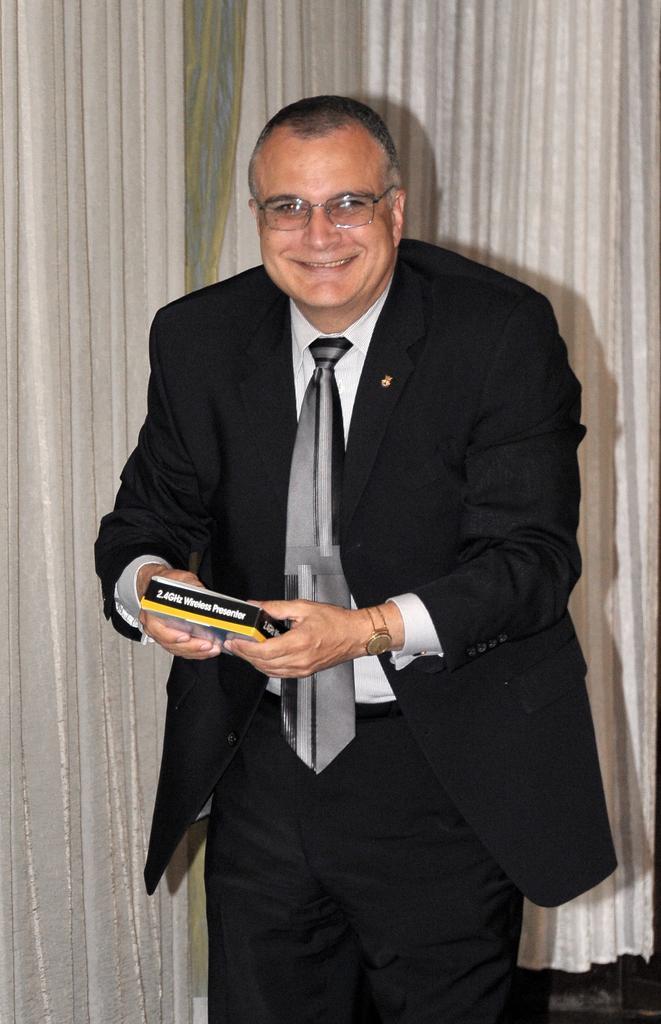Can you describe this image briefly? Here in this picture we can see a person standing over a place and we can see he is wearing black colored suit on him and carrying a book in his hand and he is smiling and wearing spectacles on him and behind him we can see a curtain present over there. 